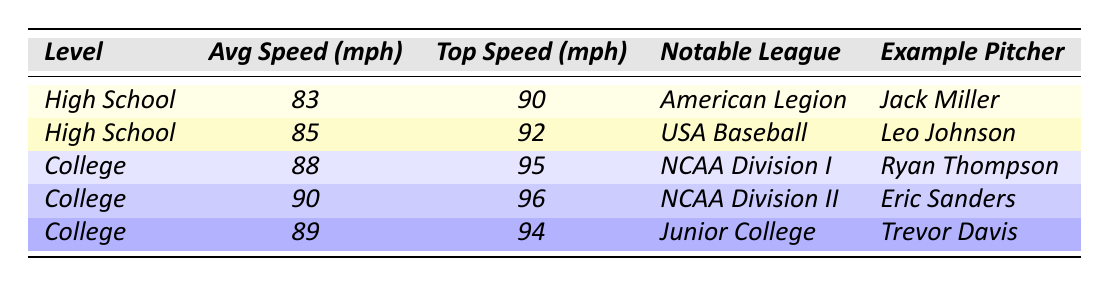What is the average pitch speed for high school pitchers? The table lists two high school pitchers with average speeds of 83 mph and 85 mph. To find the average, we add these values: 83 + 85 = 168. Then, we divide by the number of pitchers (2), which gives us 168 / 2 = 84 mph.
Answer: 84 mph What is the top pitch speed of the fastest high school pitcher? According to the table, the top pitch speed for the fastest high school pitcher (Leo Johnson) is 92 mph.
Answer: 92 mph What is the difference between the average pitch speed of college and high school pitchers? To find the difference, we take the average speed of the college pitchers, which is (88 + 90 + 89) / 3 = 89 mph. The average speed of high school pitchers calculated earlier is 84 mph. Therefore, the difference is 89 - 84 = 5 mph.
Answer: 5 mph Is there any college pitcher with an average speed below 85 mph? Reviewing the college pitchers listed in the table, all their average speeds (88, 90, 89 mph) are above 85 mph. This means there are no college pitchers with an average speed below 85 mph.
Answer: No Which notable league has the highest average pitch speed? By comparing the average pitch speeds of different notable leagues in the table, the highest average speed is from NCAA Division II at 90 mph.
Answer: NCAA Division II What is the average top pitch speed for pitchers at both levels? We first get the top speeds: 90, 92 (High School); 95, 96, 94 (College). Their sums are 90 + 92 + 95 + 96 + 94 = 467. Now we divide by the number of pitchers (5): 467 / 5 = 93.4 mph.
Answer: 93.4 mph Which high school pitcher has a notable league comparable to any college pitcher? The notable league for the high school example pitchers is American Legion and USA Baseball. Both leagues have comparable collegiate leagues, such as Junior College for Trevor Davis and NCAA Division I for Ryan Thompson.
Answer: Yes How many more miles per hour does the top college pitcher throw compared to the top high school pitcher? The top high school pitch speed is 92 mph (Leo Johnson), while the top college pitch speed is 96 mph (Eric Sanders). The difference is calculated as 96 - 92 = 4 mph.
Answer: 4 mph What is the average of the top pitch speeds for all pitchers? The top pitch speeds are 90, 92, 95, 96, and 94. We sum these: 90 + 92 + 95 + 96 + 94 = 467. Dividing by 5 gives us an average of 467 / 5 = 93.4 mph.
Answer: 93.4 mph 